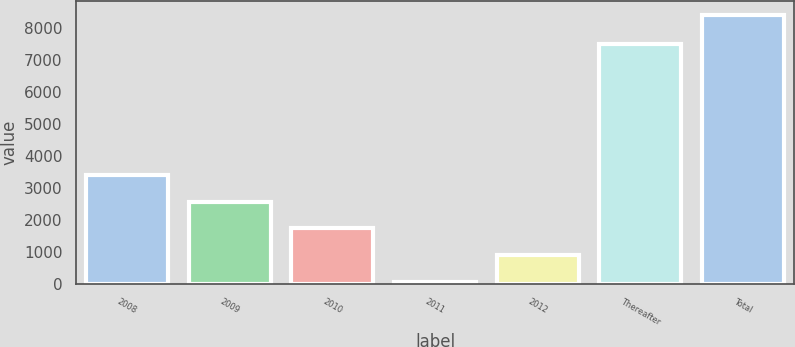Convert chart to OTSL. <chart><loc_0><loc_0><loc_500><loc_500><bar_chart><fcel>2008<fcel>2009<fcel>2010<fcel>2011<fcel>2012<fcel>Thereafter<fcel>Total<nl><fcel>3402.8<fcel>2569.6<fcel>1736.4<fcel>70<fcel>903.2<fcel>7488<fcel>8402<nl></chart> 